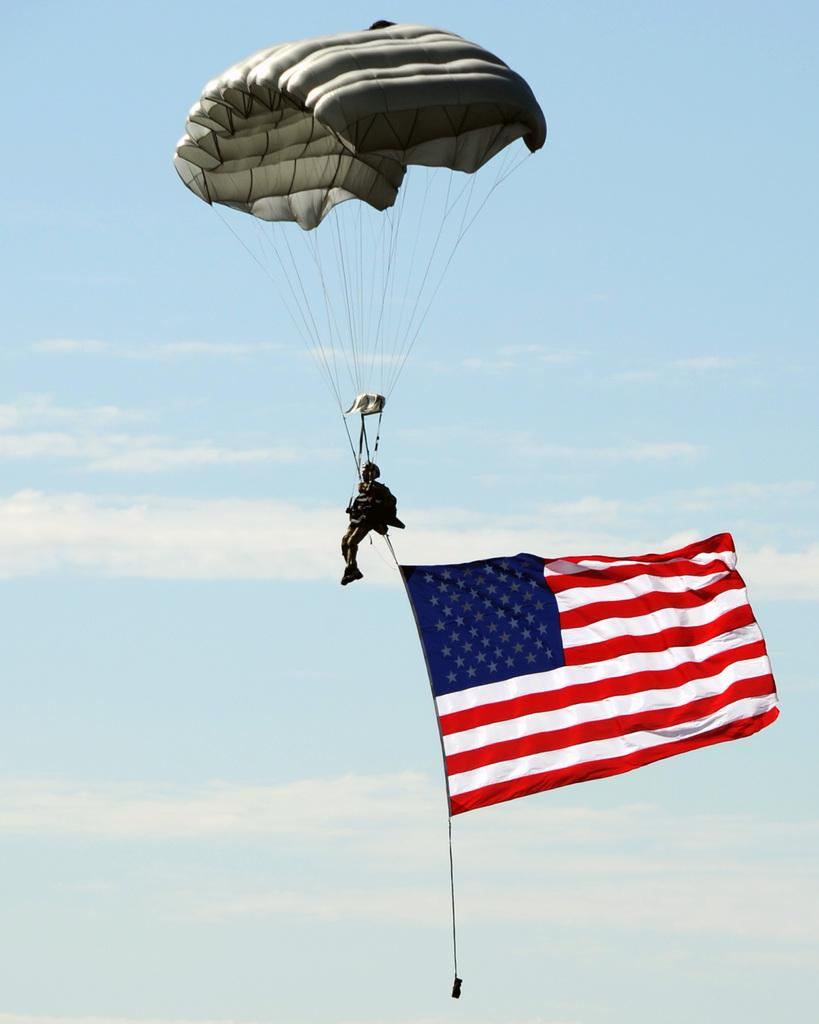What is the main subject of the image? There is a person in the image. What is the person doing in the image? The person is flying with a parachute. What else can be seen in the image besides the person? There is a flag in the image. What is visible in the background of the image? The sky is visible in the image, and clouds are present in the sky. What is the reason for the quarter being displayed in the image? There is no quarter present in the image, so there is no reason for it to be displayed. 